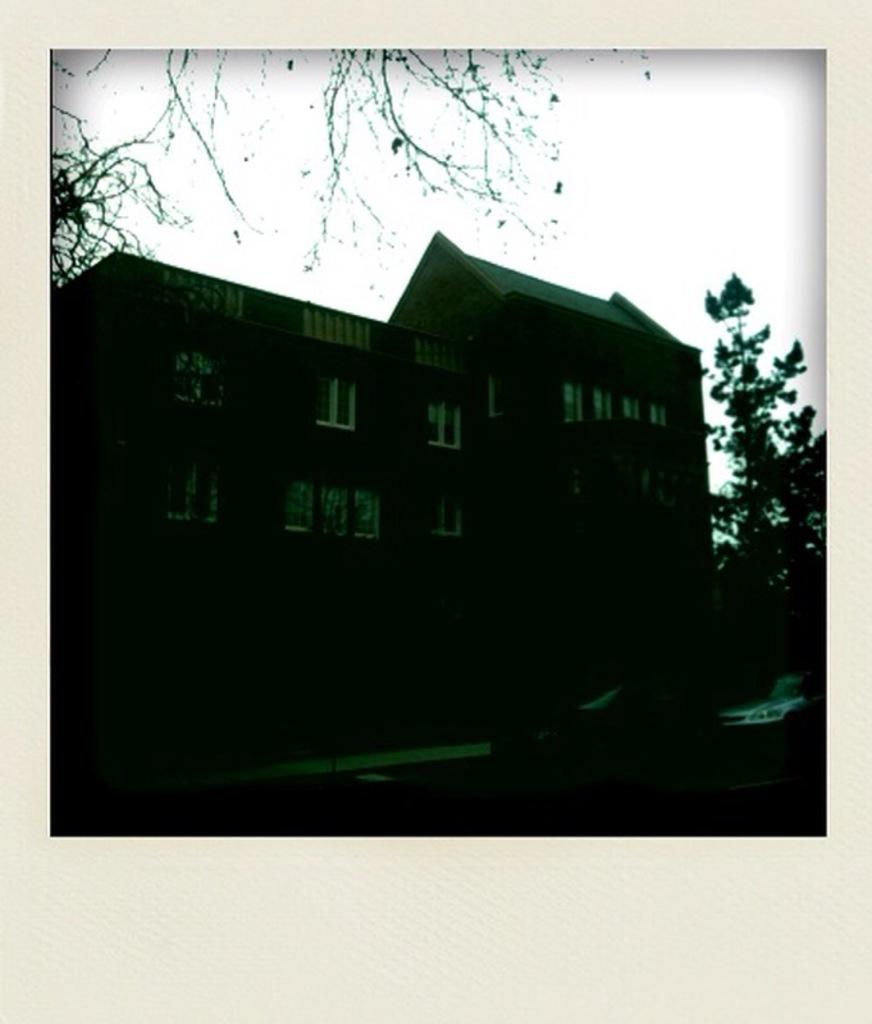What type of structure is visible in the image? There is a building in the image. What other elements can be seen in the image besides the building? There are trees in the image. How many fingers are visible in the image? There are no fingers visible in the image. What type of debt is being discussed in the image? There is no mention of debt in the image. 